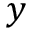<formula> <loc_0><loc_0><loc_500><loc_500>y</formula> 